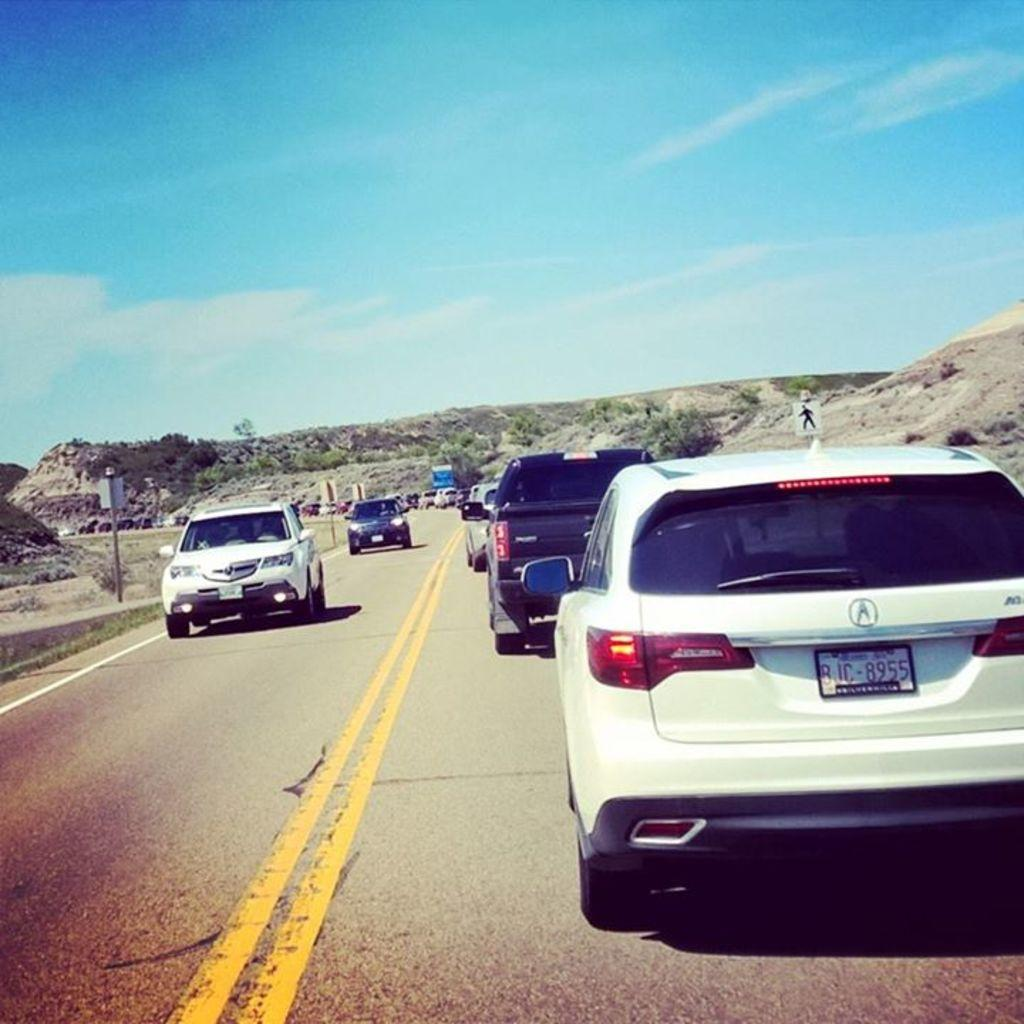What is at the bottom of the image? There is a road at the bottom of the image. What can be seen on the road? Cars are visible on the road. What is in the background of the image? There are hills and the sky visible in the background of the image. Where is the sign board located in the image? The sign board is on the left side of the image. How many toes can be seen on the cars in the image? Cars do not have toes, so none can be seen on the cars in the image. What is the temperature in the image? The image does not provide information about the temperature, so it cannot be determined. 